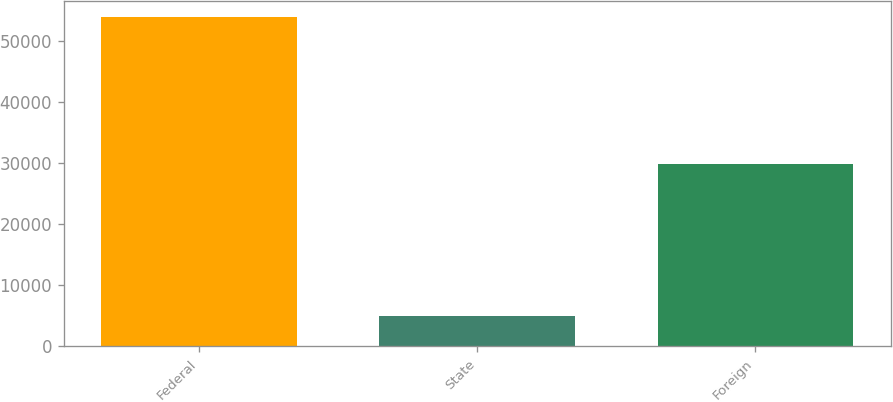Convert chart to OTSL. <chart><loc_0><loc_0><loc_500><loc_500><bar_chart><fcel>Federal<fcel>State<fcel>Foreign<nl><fcel>53937<fcel>4896<fcel>29942<nl></chart> 